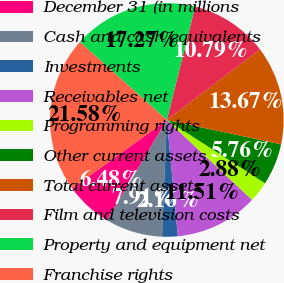<chart> <loc_0><loc_0><loc_500><loc_500><pie_chart><fcel>December 31 (in millions<fcel>Cash and cash equivalents<fcel>Investments<fcel>Receivables net<fcel>Programming rights<fcel>Other current assets<fcel>Total current assets<fcel>Film and television costs<fcel>Property and equipment net<fcel>Franchise rights<nl><fcel>6.48%<fcel>7.91%<fcel>2.16%<fcel>11.51%<fcel>2.88%<fcel>5.76%<fcel>13.67%<fcel>10.79%<fcel>17.27%<fcel>21.58%<nl></chart> 